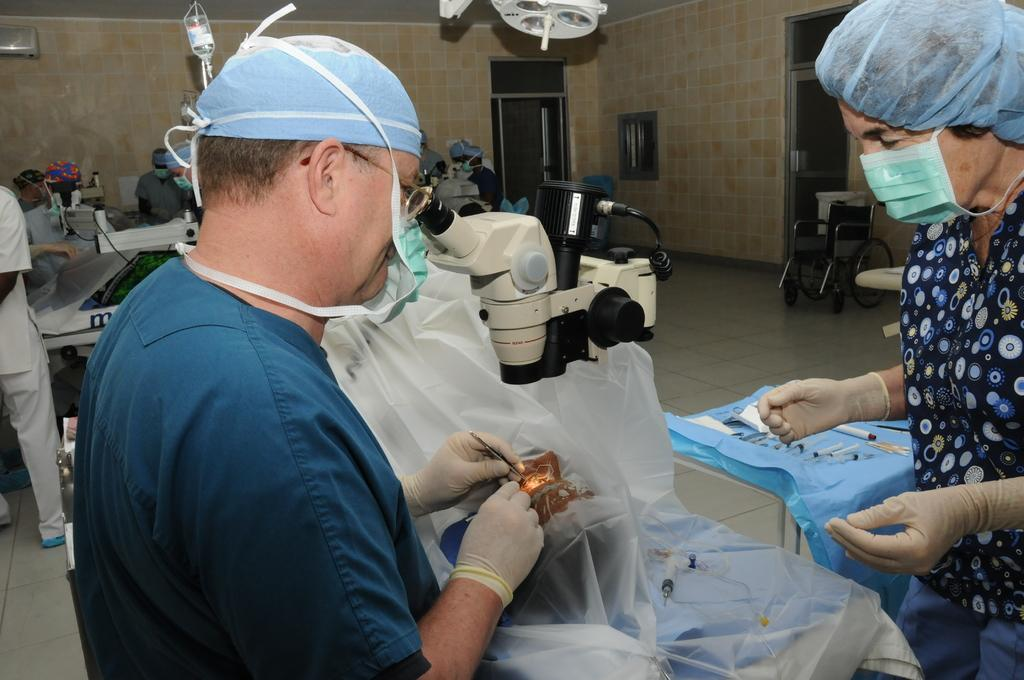What can be seen in the image besides the two persons? There is an equipment in the image. What are the two persons wearing on their faces? The persons are wearing masks on their faces. What is visible in the background of the image? There is a wall in the background of the image. Can you see any toads or rocks in the image? No, there are no toads or rocks present in the image. What type of fish can be seen swimming near the persons in the image? There are no fish present in the image. 